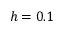<formula> <loc_0><loc_0><loc_500><loc_500>h = 0 . 1</formula> 